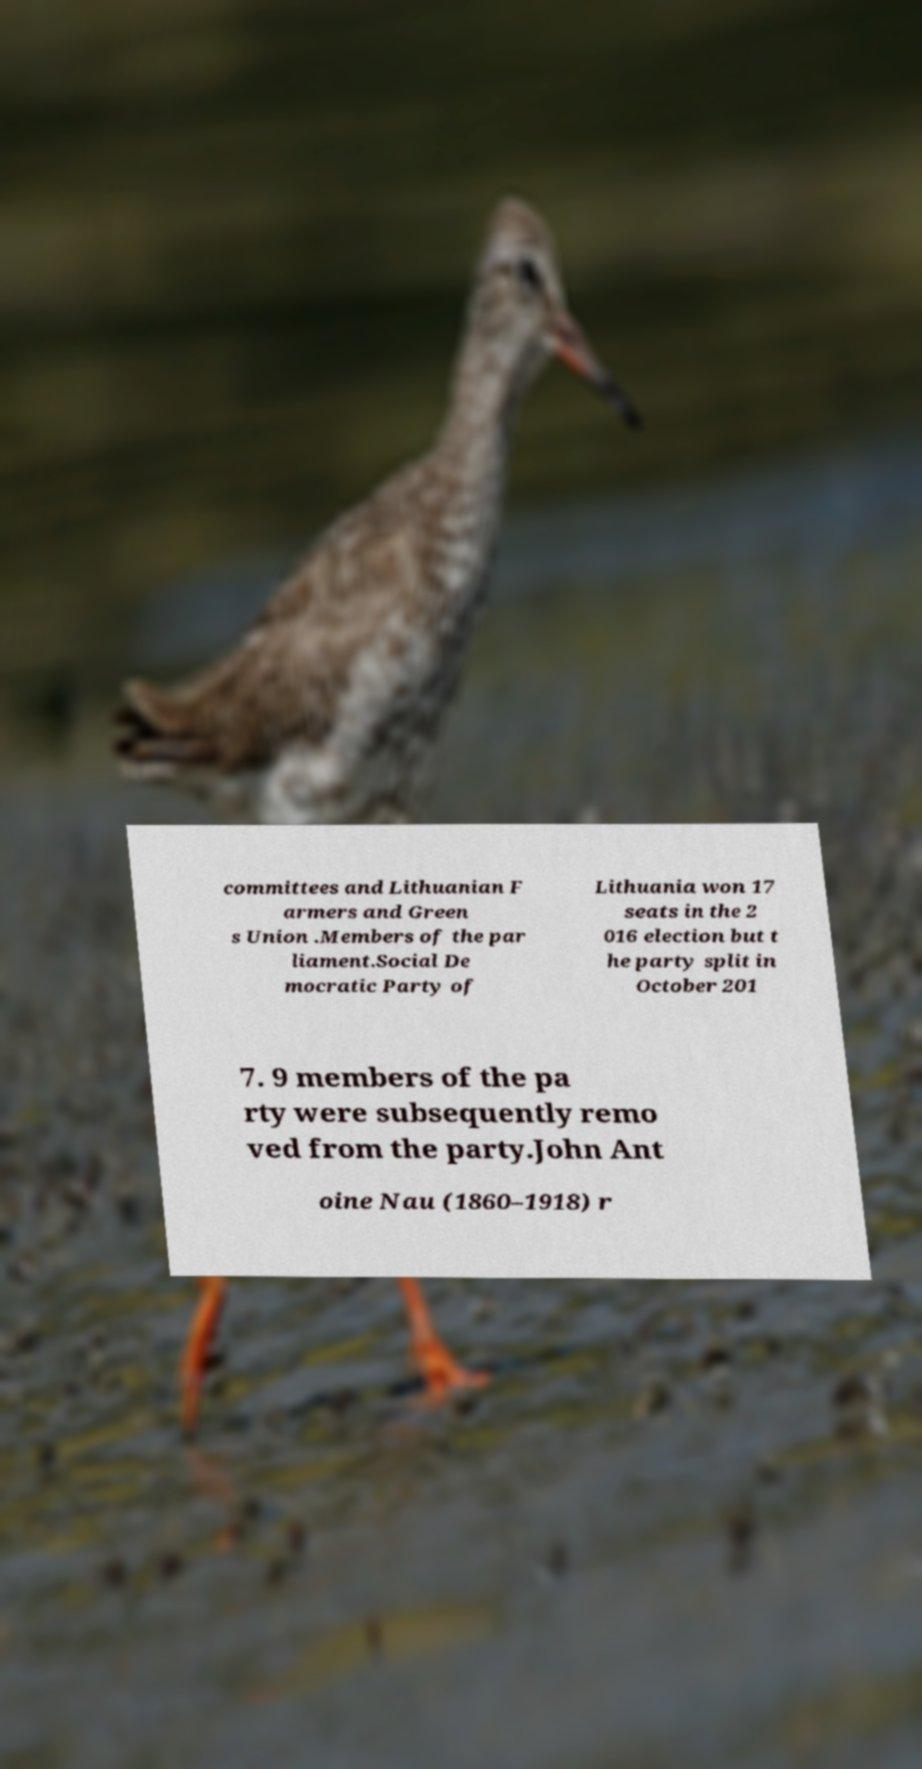Please read and relay the text visible in this image. What does it say? committees and Lithuanian F armers and Green s Union .Members of the par liament.Social De mocratic Party of Lithuania won 17 seats in the 2 016 election but t he party split in October 201 7. 9 members of the pa rty were subsequently remo ved from the party.John Ant oine Nau (1860–1918) r 